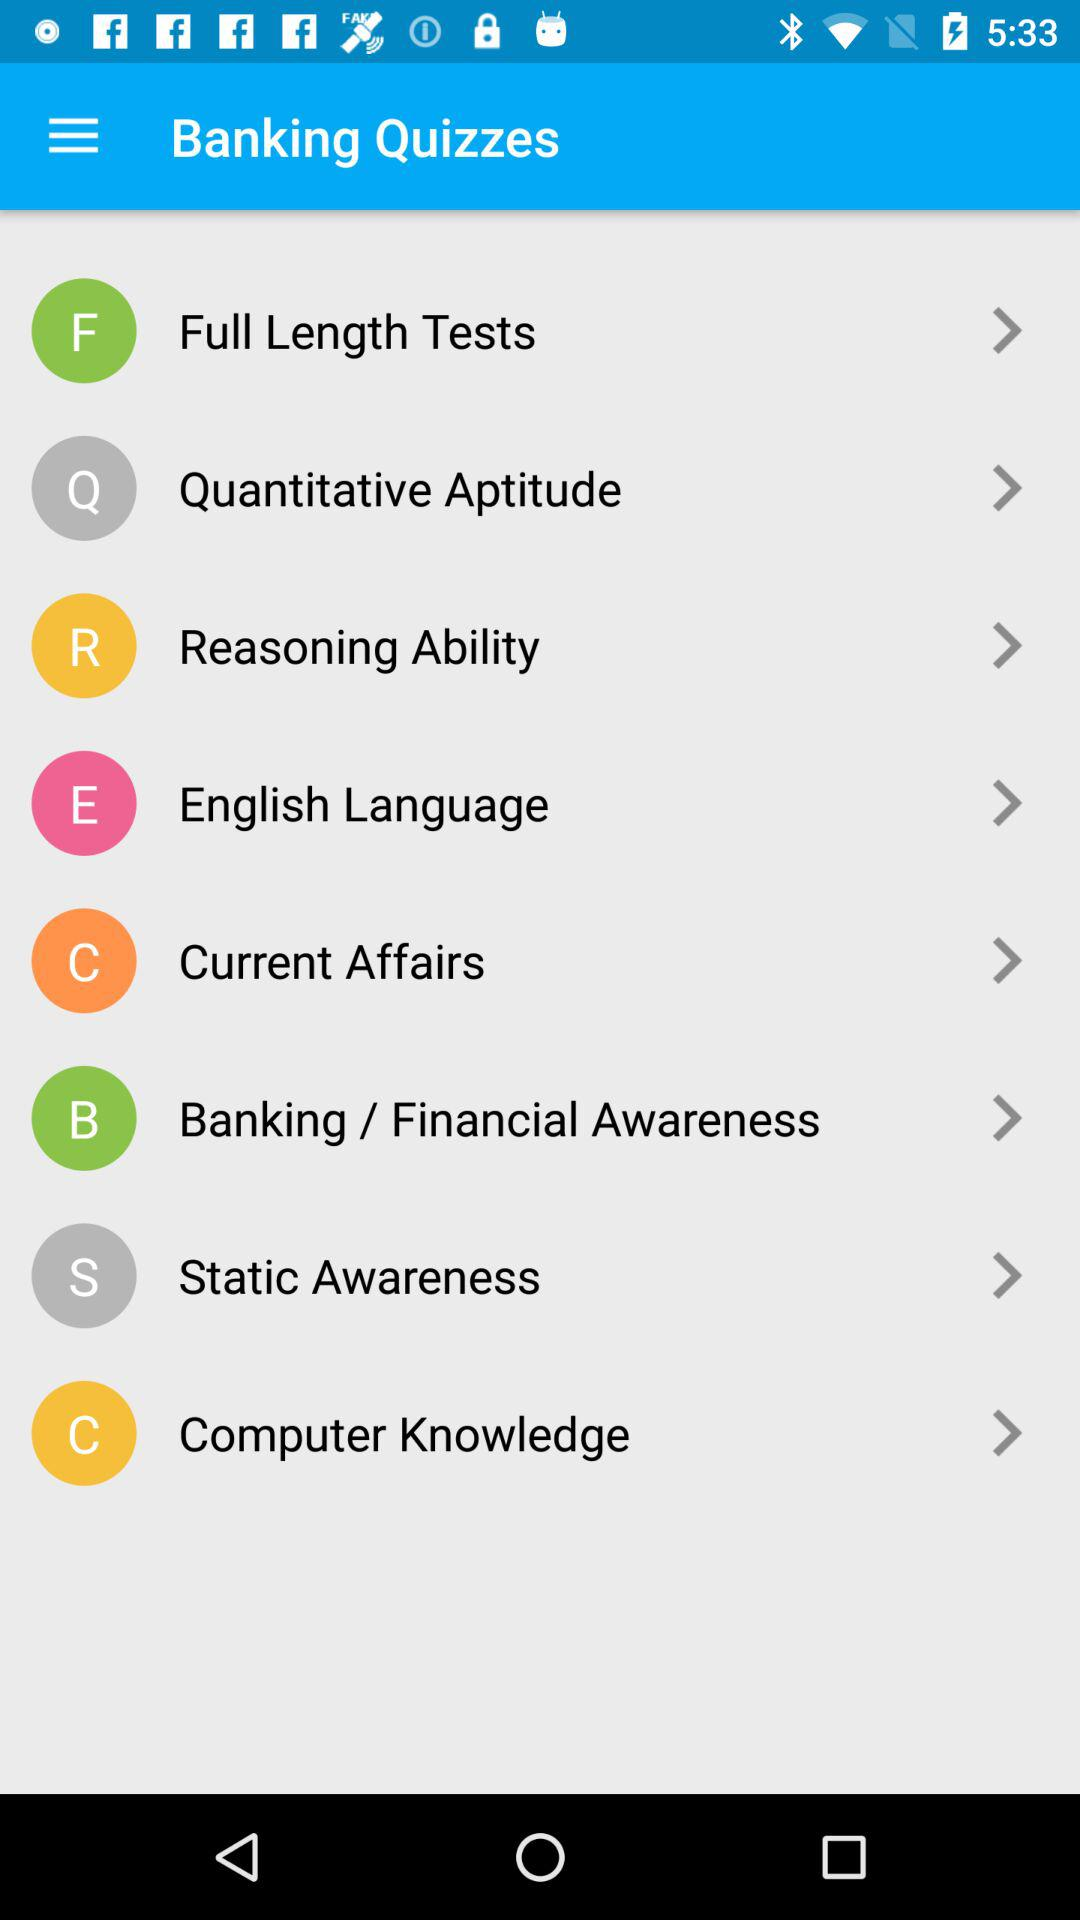What are the different categories given in "Banking Quizzes"? The different categories given in "Banking Quizzes" are "Full Length Tests", "Quantitative Aptitude", "Reasoning Ability", "English Language", "Current Affairs", "Banking / Financial Awareness", "Static Awareness" and "Computer Knowledge". 